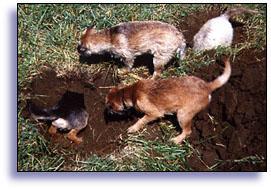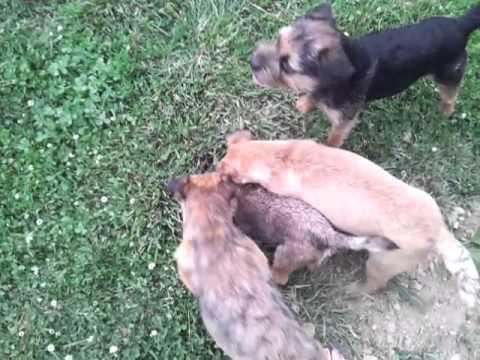The first image is the image on the left, the second image is the image on the right. Assess this claim about the two images: "There are at least two animals in the image on the right.". Correct or not? Answer yes or no. Yes. 